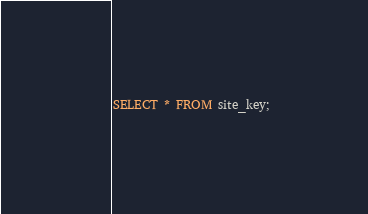<code> <loc_0><loc_0><loc_500><loc_500><_SQL_>SELECT * FROM site_key;
</code> 